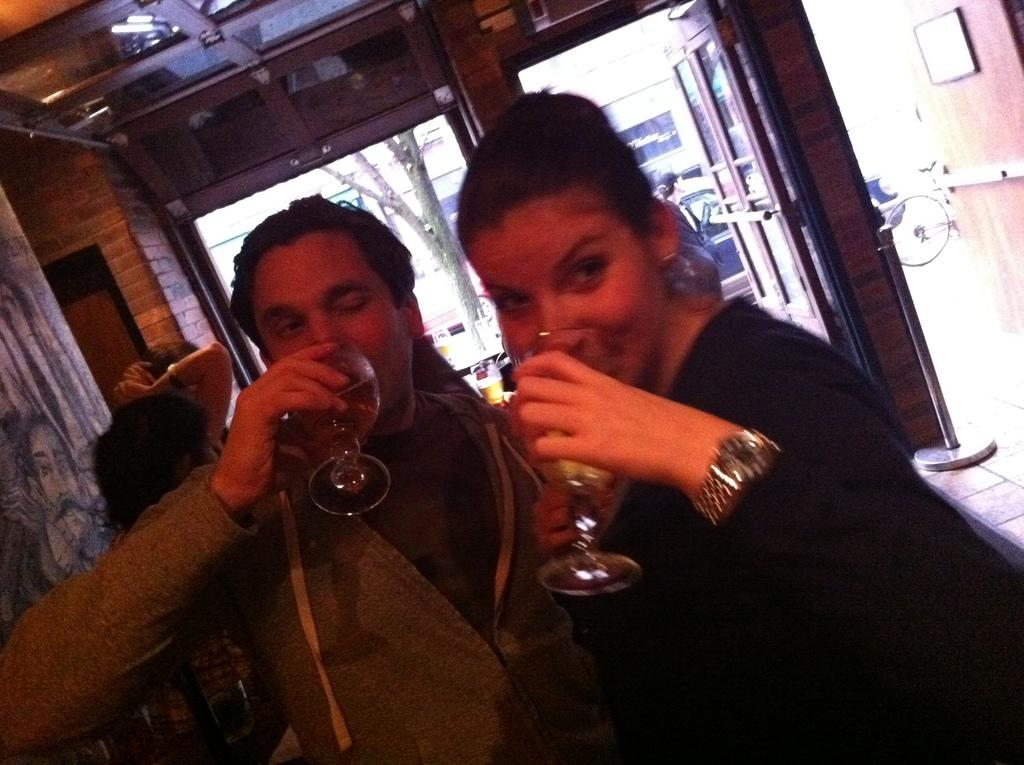Who is present in the image? There is a man and a woman in the image. Where are the man and woman located in the image? The man and woman are at the center of the image. What are the man and woman doing in the image? The man and woman are drinking juice. What architectural feature can be seen in the image? There is a door visible in the image. What type of friction is present between the man and woman in the image? There is no indication of friction between the man and woman in the image; they are simply drinking juice together. Can you see a knife in the image? No, there is no knife present in the image. 